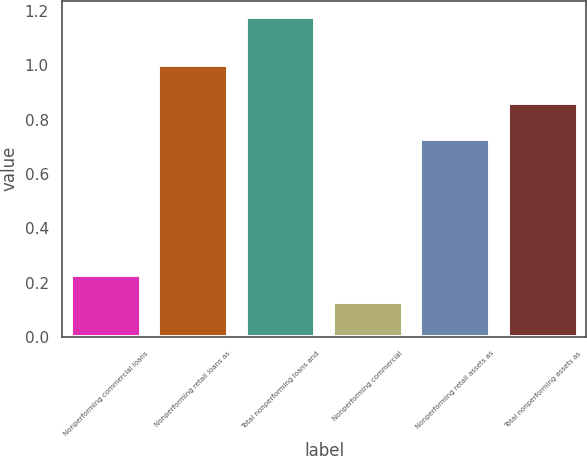<chart> <loc_0><loc_0><loc_500><loc_500><bar_chart><fcel>Nonperforming commercial loans<fcel>Nonperforming retail loans as<fcel>Total nonperforming loans and<fcel>Nonperforming commercial<fcel>Nonperforming retail assets as<fcel>Total nonperforming assets as<nl><fcel>0.23<fcel>1<fcel>1.18<fcel>0.13<fcel>0.73<fcel>0.86<nl></chart> 